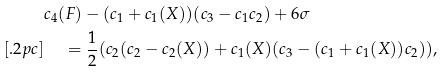Convert formula to latex. <formula><loc_0><loc_0><loc_500><loc_500>& c _ { 4 } ( F ) - ( c _ { 1 } + c _ { 1 } ( X ) ) ( c _ { 3 } - c _ { 1 } c _ { 2 } ) + 6 \sigma \\ [ . 2 p c ] & \quad \, = \frac { 1 } { 2 } ( c _ { 2 } ( c _ { 2 } - c _ { 2 } ( X ) ) + c _ { 1 } ( X ) ( c _ { 3 } - ( c _ { 1 } + c _ { 1 } ( X ) ) c _ { 2 } ) ) ,</formula> 